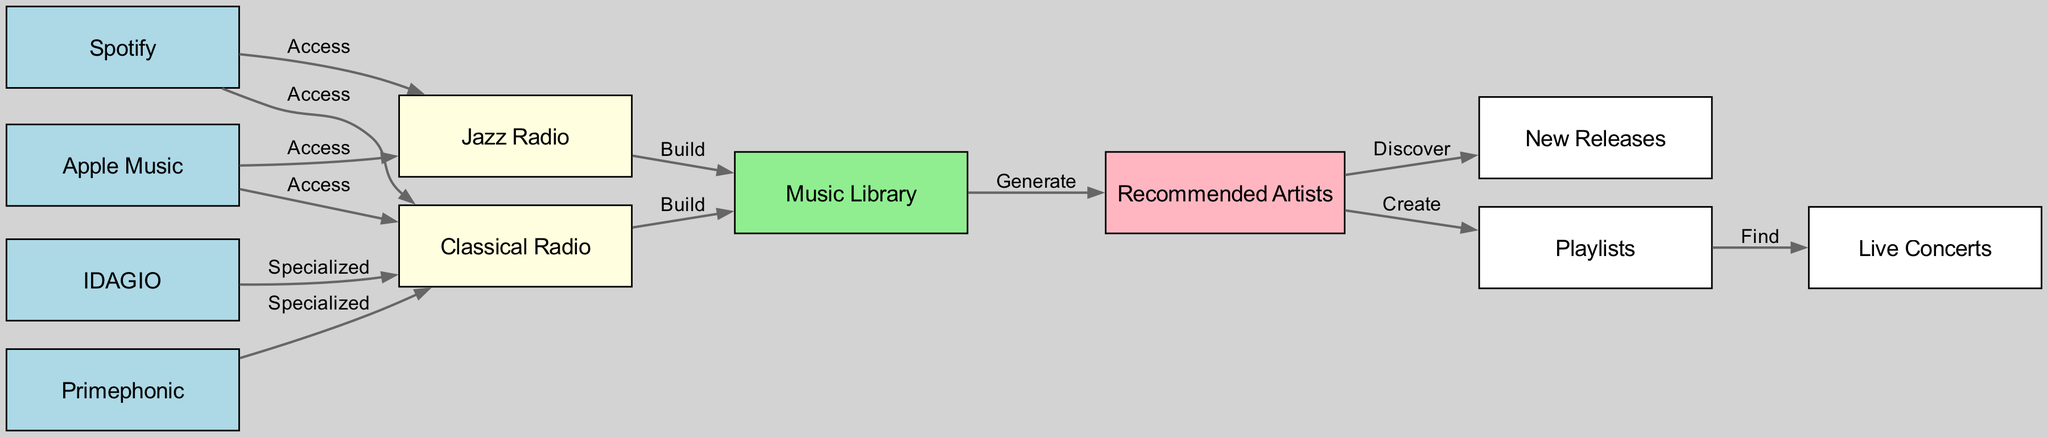What are the two main streaming platforms for jazz and classical music in this diagram? The diagram shows four nodes of main streaming platforms: Spotify, Apple Music, IDAGIO, and Primephonic. From analysis, the two that are highlighted as common access points for both music genres are Spotify and Apple Music.
Answer: Spotify, Apple Music How many total nodes are present in the diagram? By counting the nodes listed in the diagram, there are 11 nodes, which include platforms, radio stations, and actions related to music discovery.
Answer: 11 Which radio station is connected to IDAGIO? The diagram indicates that IDAGIO specifically connects to Classical Radio, showing its specialized focus for that genre, indicating this relationship's direction is towards enriching classical music use.
Answer: Classical Radio What is the role of the Music Library in the diagram? The Music Library plays a central role as it is connected to both Jazz Radio and Classical Radio, and it further directs to Recommended Artists. This indicates it serves as a foundational space where user data is collected to generate artist recommendations.
Answer: Generate recommendations How many edges connect to Recommended Artists? The edges connecting to Recommended Artists include two directed edges: one coming from Music Library and another leading to New Releases and Playlists. By counting these, we find that three edges connect to Recommended Artists.
Answer: 3 Which platform specializes in Classical Radio according to the diagram? The diagram indicates two specific platforms that have a specialized role in connection to Classical Radio: IDAGIO and Primephonic. Therefore, both platforms specialize in this type of music content.
Answer: IDAGIO, Primephonic What can be found through Playlists as shown in the diagram? Playlists in the diagram lead to Live Concerts according to the flow of the directed edges, suggesting that users can discover live performances through curated playlists.
Answer: Live Concerts What music genre does Jazz Radio primarily focus on? Jazz Radio as clearly indicated in the diagram focuses exclusively on jazz music, as implied by its connections and the labels of the directed edges leading from platforms.
Answer: Jazz How does a user discover new artists based on the flow in the diagram? The flow for discovering new artists typically starts from the Music Library, which generates recommendations that lead to new releases. This sequence indicates that users are funneling through actively personalized music choices to find new artists.
Answer: Through Music Library to Recommended Artists to New Releases 